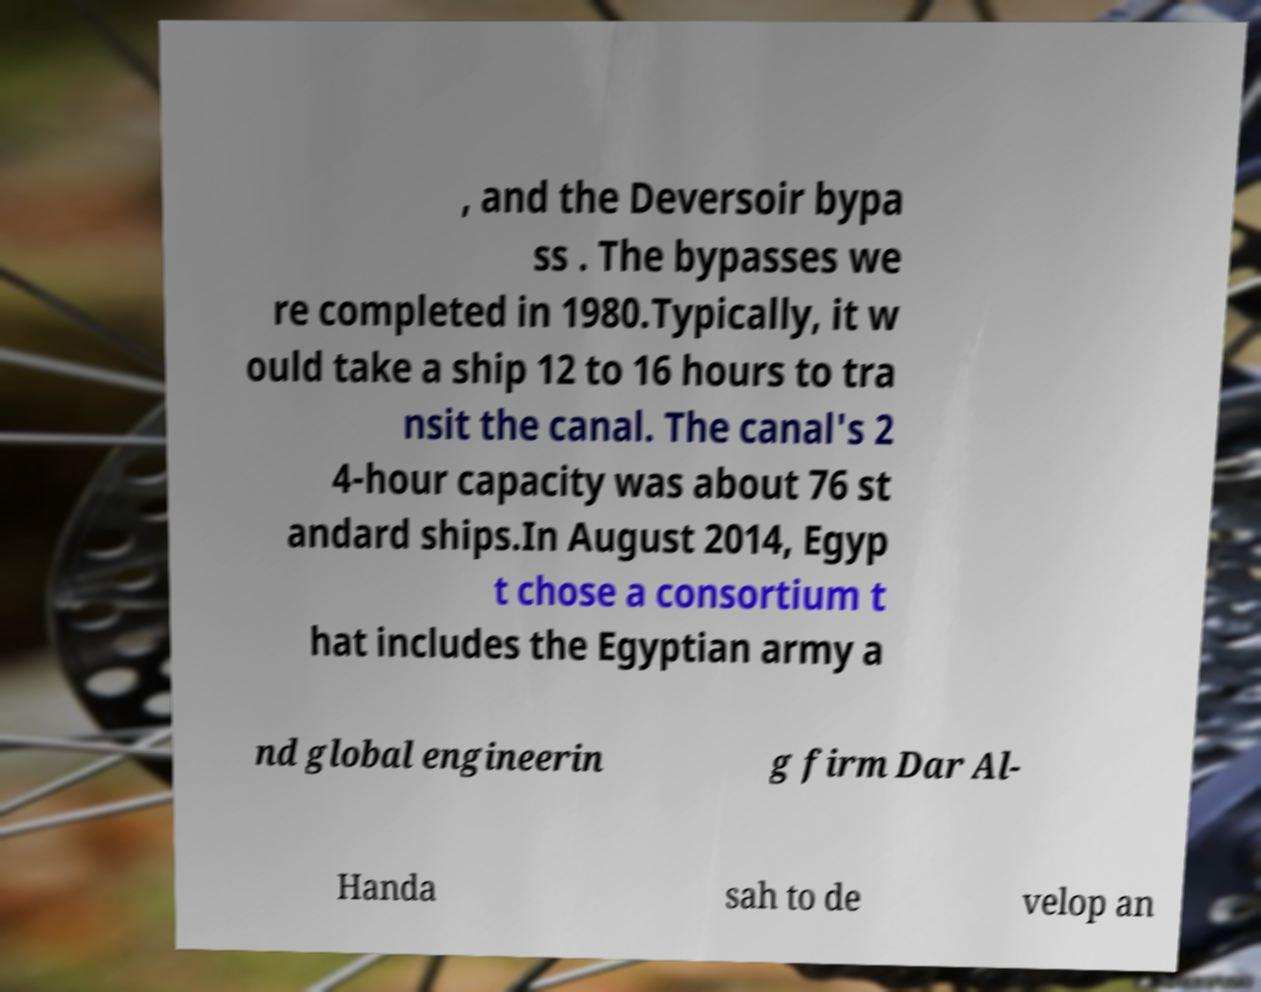I need the written content from this picture converted into text. Can you do that? , and the Deversoir bypa ss . The bypasses we re completed in 1980.Typically, it w ould take a ship 12 to 16 hours to tra nsit the canal. The canal's 2 4-hour capacity was about 76 st andard ships.In August 2014, Egyp t chose a consortium t hat includes the Egyptian army a nd global engineerin g firm Dar Al- Handa sah to de velop an 